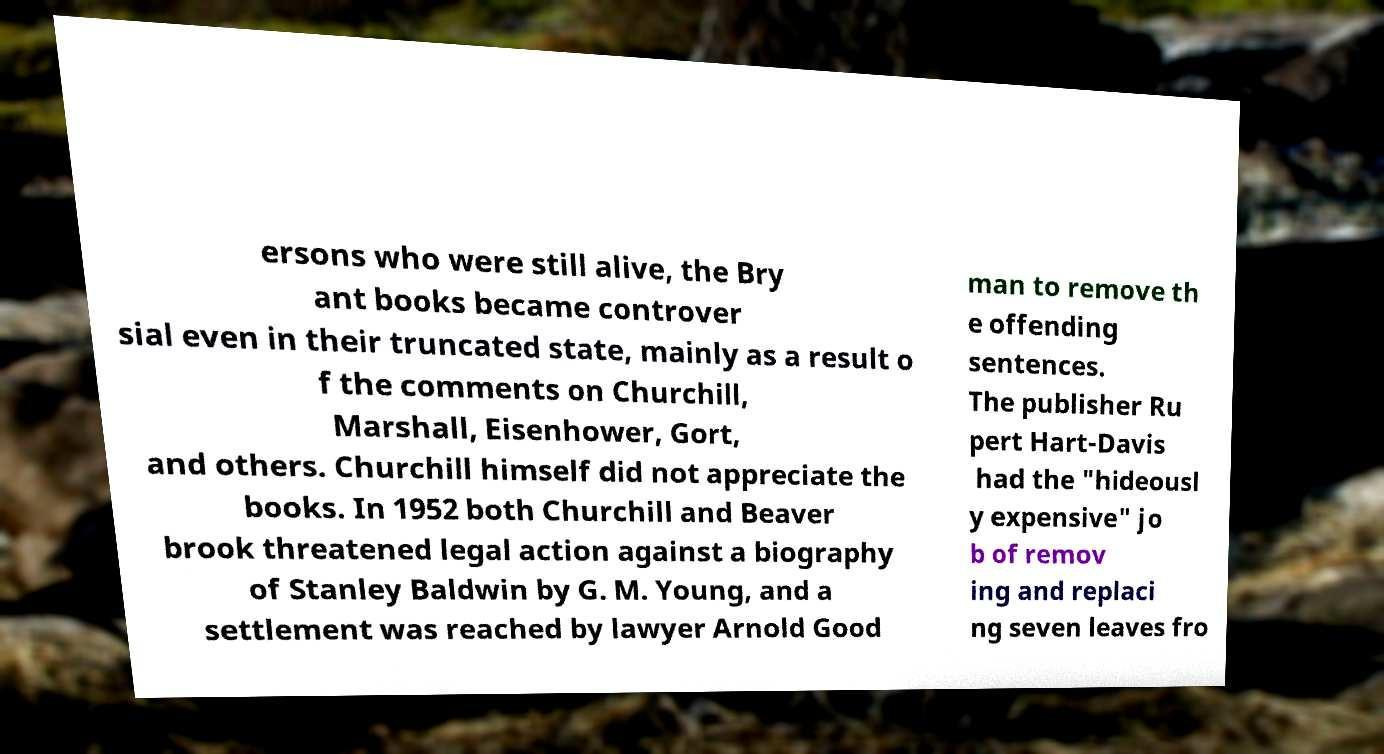There's text embedded in this image that I need extracted. Can you transcribe it verbatim? ersons who were still alive, the Bry ant books became controver sial even in their truncated state, mainly as a result o f the comments on Churchill, Marshall, Eisenhower, Gort, and others. Churchill himself did not appreciate the books. In 1952 both Churchill and Beaver brook threatened legal action against a biography of Stanley Baldwin by G. M. Young, and a settlement was reached by lawyer Arnold Good man to remove th e offending sentences. The publisher Ru pert Hart-Davis had the "hideousl y expensive" jo b of remov ing and replaci ng seven leaves fro 